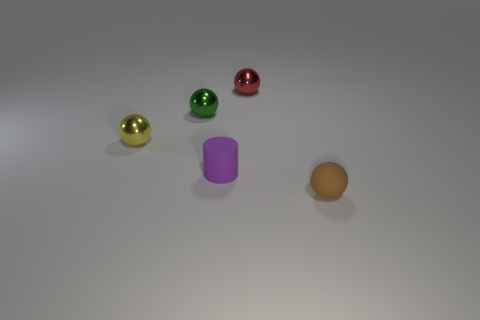Subtract all red spheres. How many spheres are left? 3 Subtract all tiny red spheres. How many spheres are left? 3 Subtract all purple balls. Subtract all green blocks. How many balls are left? 4 Add 3 small yellow blocks. How many objects exist? 8 Subtract all balls. How many objects are left? 1 Add 3 small purple cylinders. How many small purple cylinders are left? 4 Add 5 yellow things. How many yellow things exist? 6 Subtract 0 gray cylinders. How many objects are left? 5 Subtract all small green shiny balls. Subtract all tiny green cylinders. How many objects are left? 4 